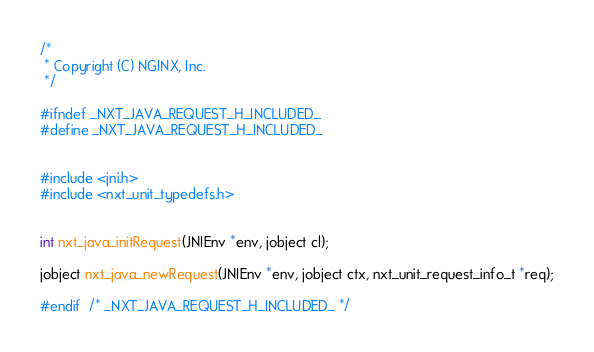<code> <loc_0><loc_0><loc_500><loc_500><_C_>
/*
 * Copyright (C) NGINX, Inc.
 */

#ifndef _NXT_JAVA_REQUEST_H_INCLUDED_
#define _NXT_JAVA_REQUEST_H_INCLUDED_


#include <jni.h>
#include <nxt_unit_typedefs.h>


int nxt_java_initRequest(JNIEnv *env, jobject cl);

jobject nxt_java_newRequest(JNIEnv *env, jobject ctx, nxt_unit_request_info_t *req);

#endif  /* _NXT_JAVA_REQUEST_H_INCLUDED_ */
</code> 